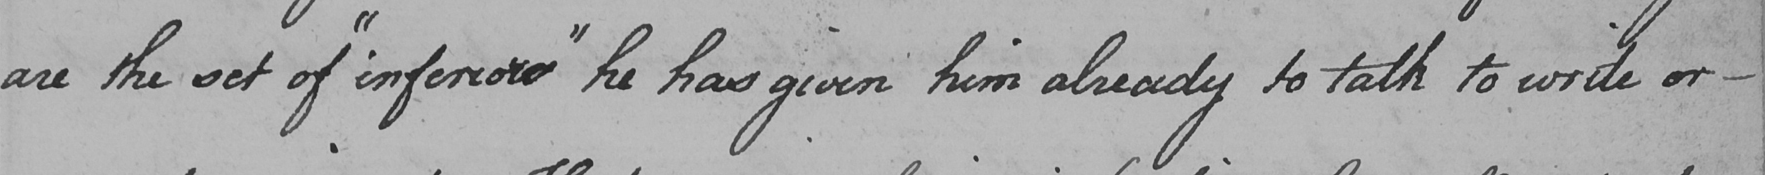Can you tell me what this handwritten text says? are the set of  " inferiors "  he has given him already to talk to write or  _ 